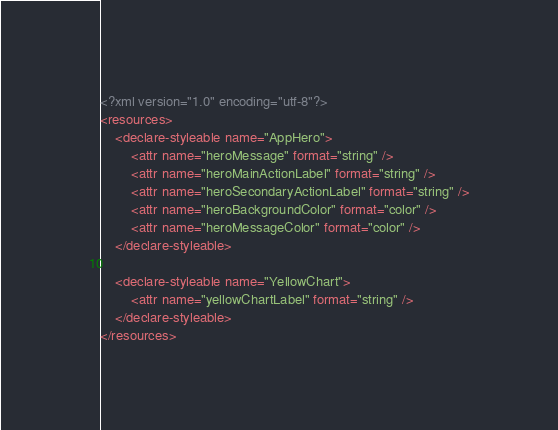<code> <loc_0><loc_0><loc_500><loc_500><_XML_><?xml version="1.0" encoding="utf-8"?>
<resources>
    <declare-styleable name="AppHero">
        <attr name="heroMessage" format="string" />
        <attr name="heroMainActionLabel" format="string" />
        <attr name="heroSecondaryActionLabel" format="string" />
        <attr name="heroBackgroundColor" format="color" />
        <attr name="heroMessageColor" format="color" />
    </declare-styleable>

    <declare-styleable name="YellowChart">
        <attr name="yellowChartLabel" format="string" />
    </declare-styleable>
</resources>
</code> 